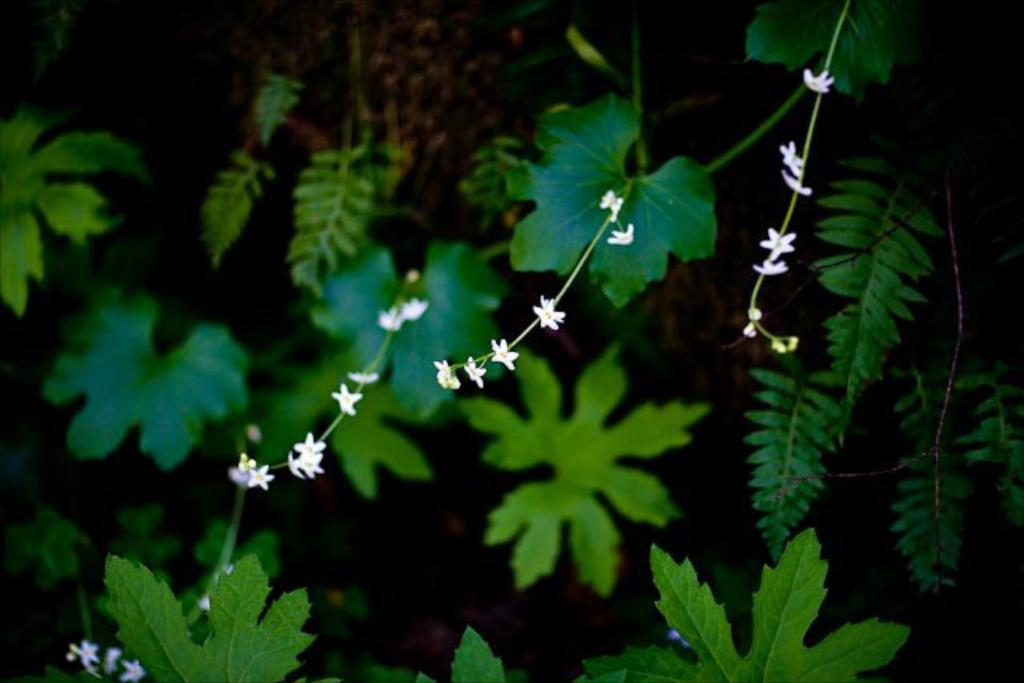Where was the image taken? The image was taken outdoors. What can be seen in the image besides the outdoor setting? There are plants in the image. What color are the leaves of the plants? The leaves of the plants are green. What other features do the plants have? The plants have stems and white flowers. What type of honey can be seen dripping from the pail in the image? There is no pail or honey present in the image; it features plants with green leaves, stems, and white flowers. What kind of fowl can be seen perched on the plants in the image? There are no fowl present in the image; it only features plants with green leaves, stems, and white flowers. 